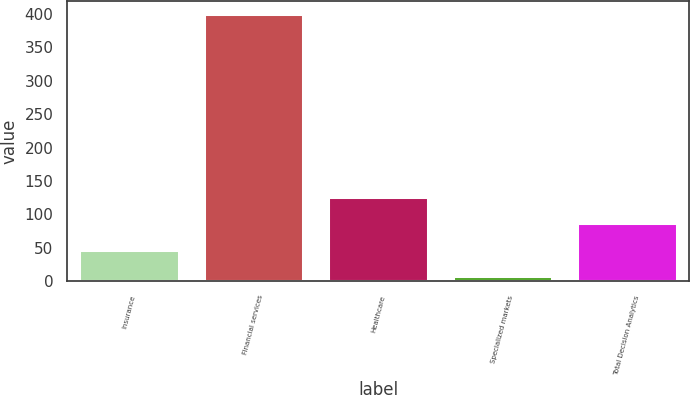Convert chart to OTSL. <chart><loc_0><loc_0><loc_500><loc_500><bar_chart><fcel>Insurance<fcel>Financial services<fcel>Healthcare<fcel>Specialized markets<fcel>Total Decision Analytics<nl><fcel>47.38<fcel>399.1<fcel>125.54<fcel>8.3<fcel>86.46<nl></chart> 